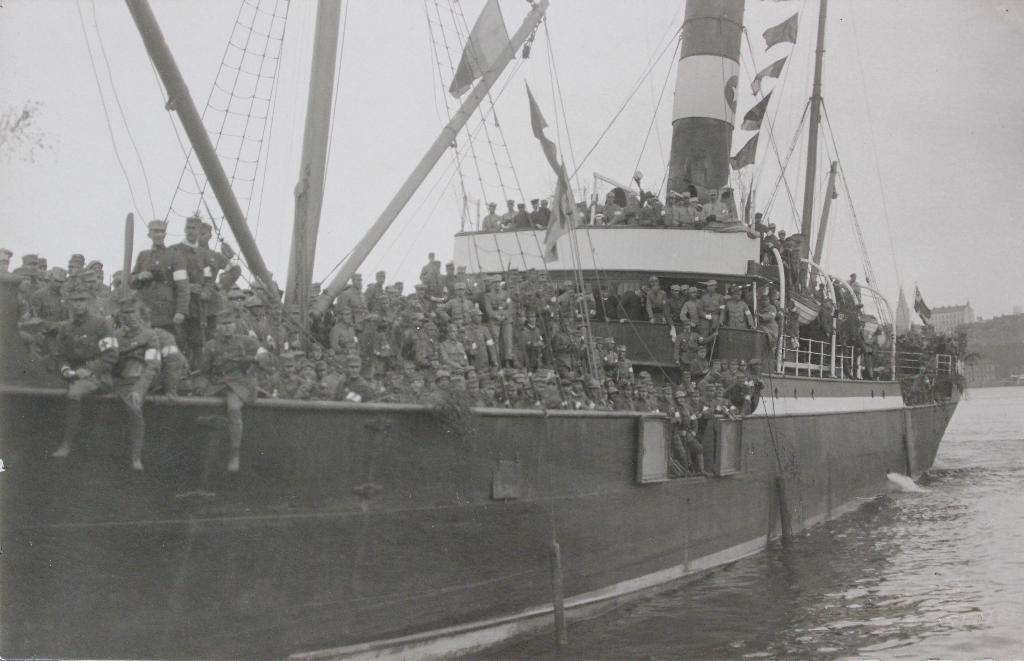Describe this image in one or two sentences. In this picture we can see a ship on the water with a group of people, poles, flags, fence, nets on it and in the background we can see a building, sky. 